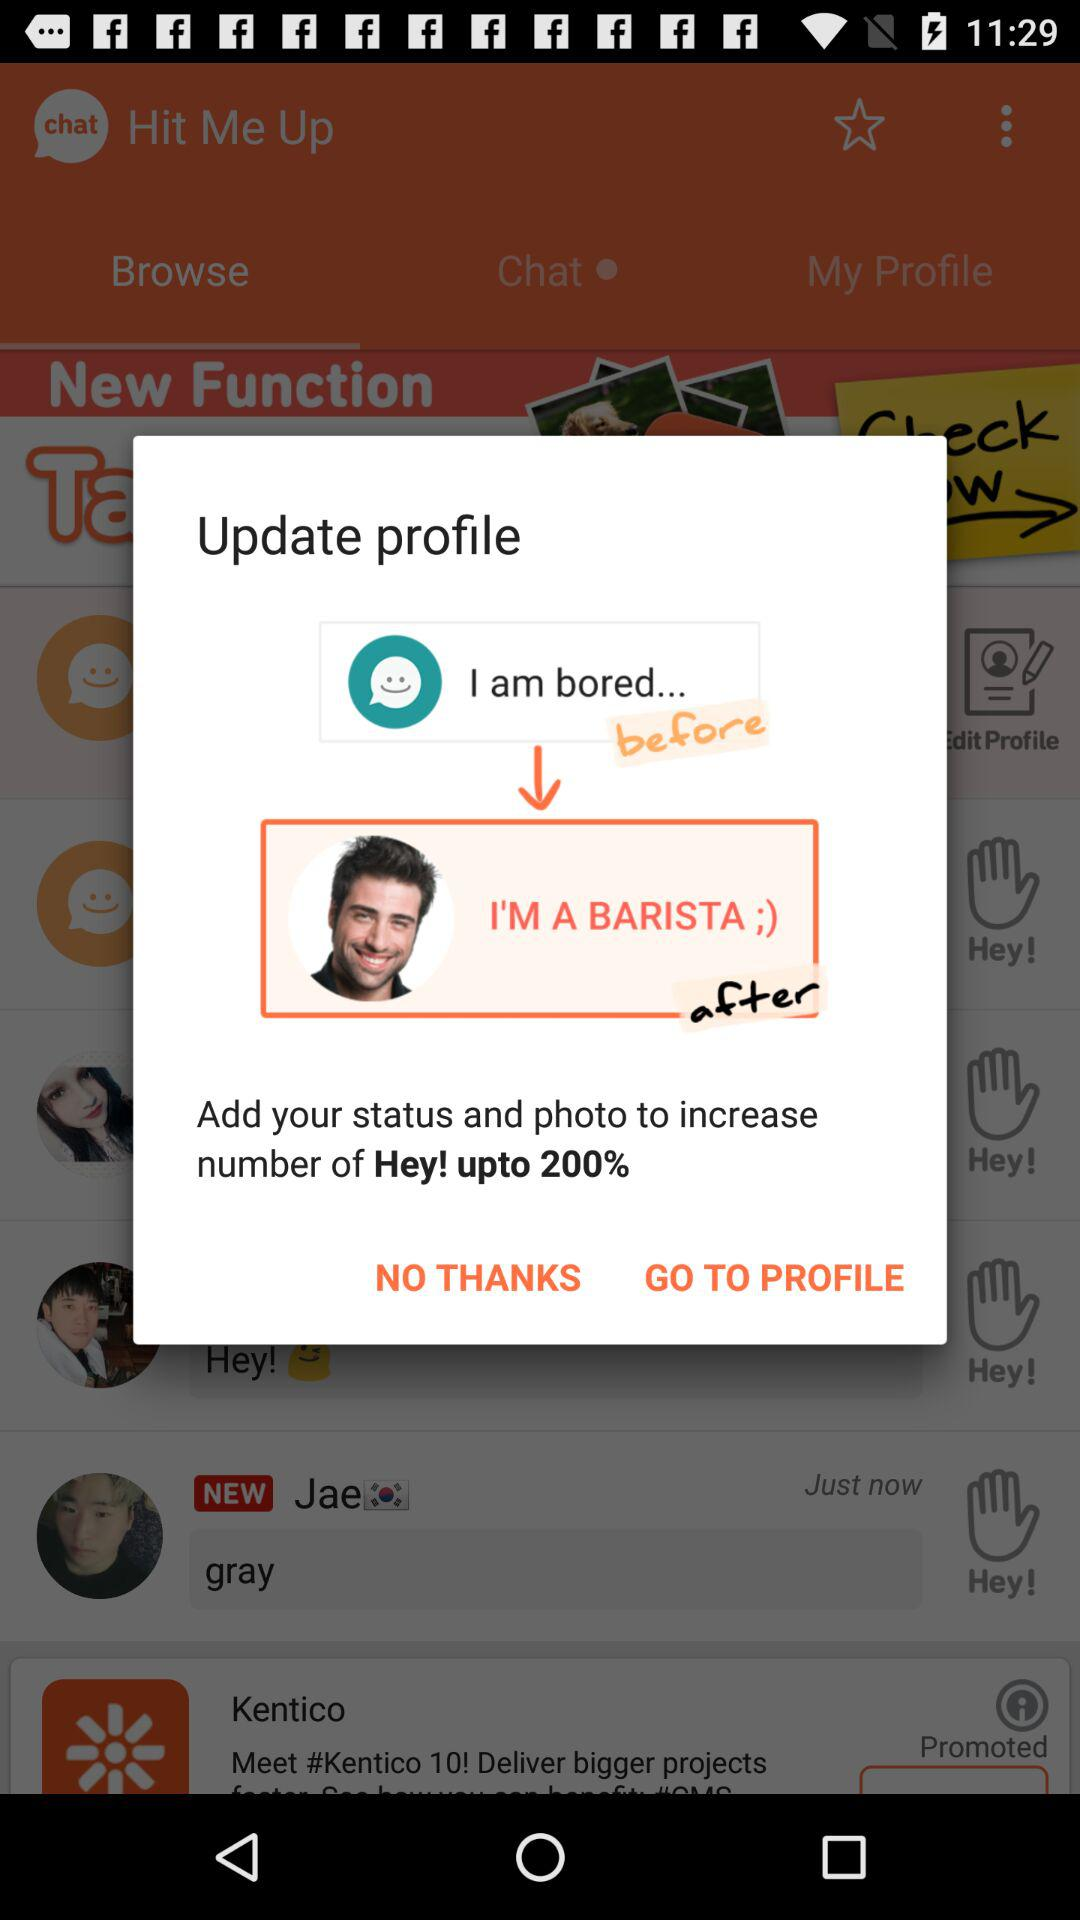What is User Name?
When the provided information is insufficient, respond with <no answer>. <no answer> 